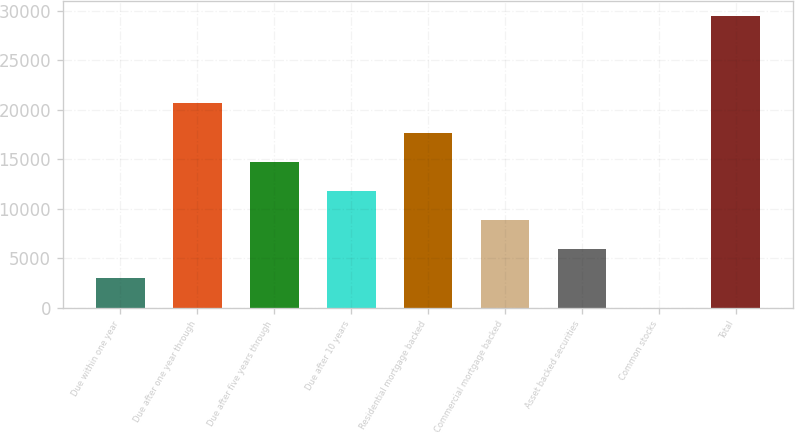Convert chart to OTSL. <chart><loc_0><loc_0><loc_500><loc_500><bar_chart><fcel>Due within one year<fcel>Due after one year through<fcel>Due after five years through<fcel>Due after 10 years<fcel>Residential mortgage backed<fcel>Commercial mortgage backed<fcel>Asset backed securities<fcel>Common stocks<fcel>Total<nl><fcel>2956.2<fcel>20633.4<fcel>14741<fcel>11794.8<fcel>17687.2<fcel>8848.6<fcel>5902.4<fcel>10<fcel>29472<nl></chart> 